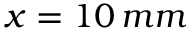<formula> <loc_0><loc_0><loc_500><loc_500>x = 1 0 \, m m</formula> 